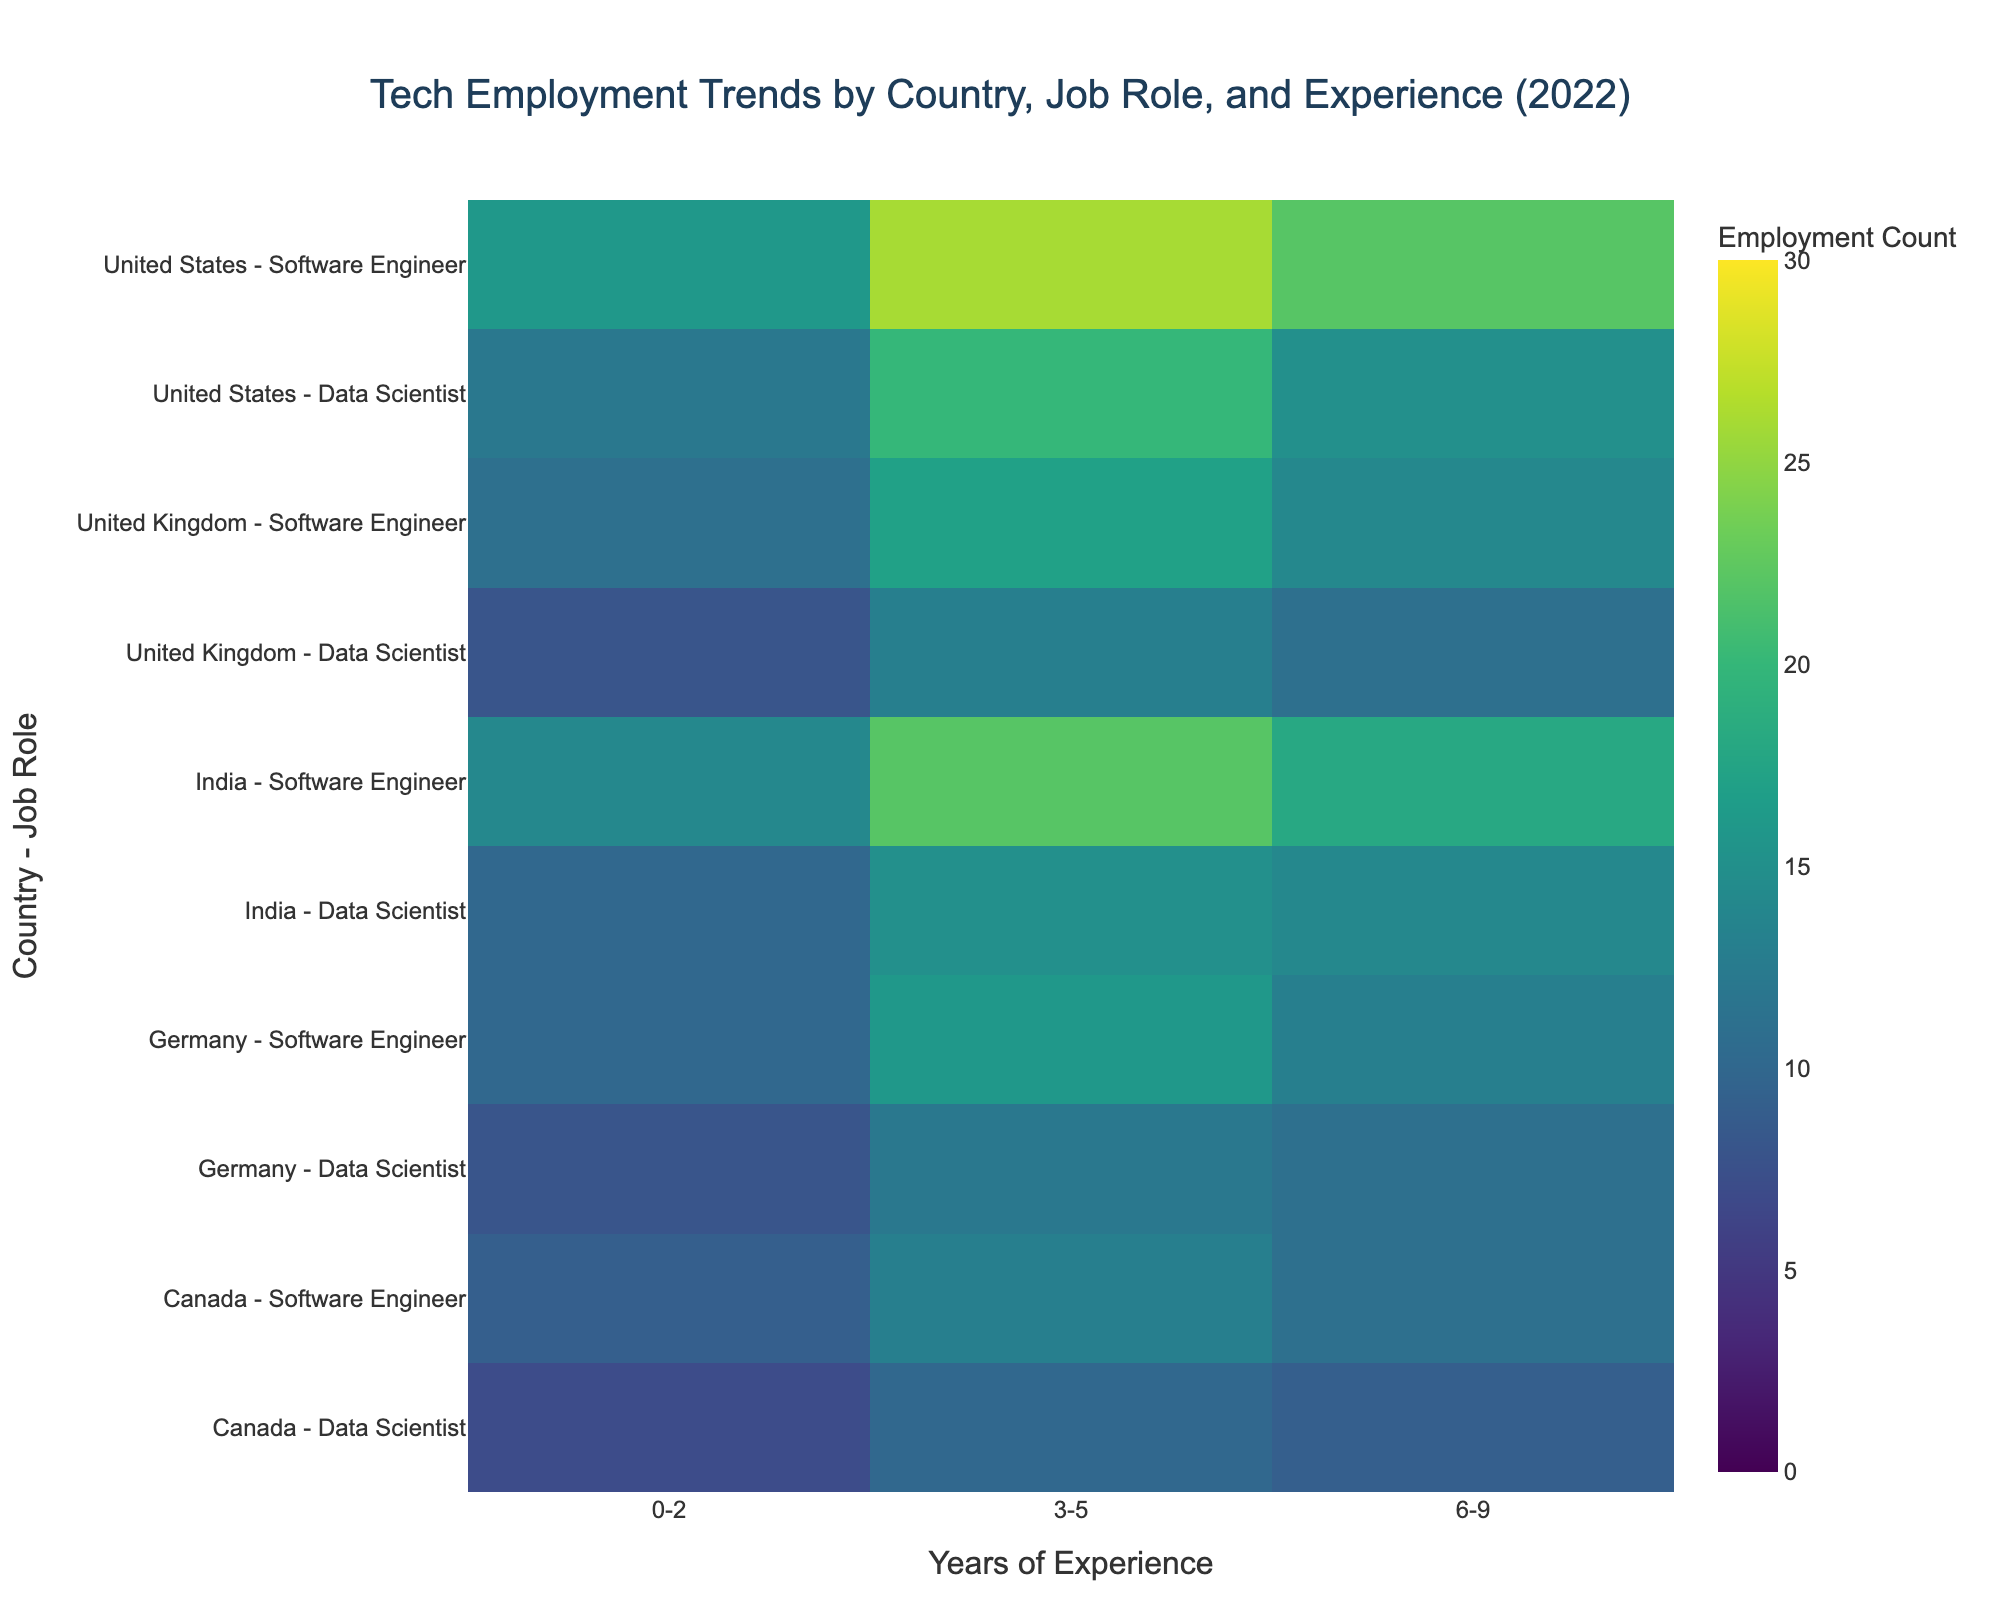What is the title of the heatmap? The title is displayed prominently at the top of the figure, indicating the main subject of the visualization. It reads: "Tech Employment Trends by Country, Job Role, and Experience (2022)."
Answer: Tech Employment Trends by Country, Job Role, and Experience (2022) How many job roles are represented in the heatmap? The y-axis labels are formatted as "Country - Job Role," and each job role repeats across multiple countries. By observing the distinct job roles listed, we see there are two: "Software Engineer" and "Data Scientist."
Answer: 2 Which country has the highest employment count for Software Engineers with 6-9 years of experience? The heatmap cells corresponding to "6-9 years of experience" in the row labels with "Software Engineer" should be examined. Notably, the United States has the darkest cell, indicating the highest count.
Answer: United States What is the employment count for Data Scientists with 0-2 years of experience in the United States? Locate the row labeled "United States - Data Scientist" and follow it to the column for "0-2 years of experience." The value displayed is the employment count.
Answer: 12 Which job role in India shows a higher count for 3-5 years of experience: Software Engineer or Data Scientist? Compare the cells corresponding to the "3-5 years of experience" column for rows labeled "India - Software Engineer" and "India - Data Scientist." "India - Software Engineer" shows a higher count.
Answer: Software Engineer What is the total employment count for Data Scientists with 3-5 years of experience across all countries? Summing up the values in the "3-5 years of experience" column for the "Data Scientist" rows across all countries: 20 (US) + 10 (Canada) + 12 (Germany) + 15 (India) + 13 (UK). The sum is 20 + 10 + 12 + 15 + 13.
Answer: 70 Which country has the least employment count for Software Engineers with 0-2 years of experience? Identify the row labels with "Software Engineer" and check the "0-2 years of experience" column. Canada has the least count among these values.
Answer: Canada How does the employment trend for Software Engineers with 6-9 years of experience differ between the United States and Germany? Compare the cells in "6-9 years of experience" for "United States - Software Engineer" and "Germany - Software Engineer." The United States shows higher employment counts in each year's data as compared to Germany.
Answer: United States has higher counts Which country shows the most balanced employment count across all years of experience for Data Scientists? Visual comparisons across the "Data Scientist" rows and columns will be needed to identify the country with the least variability in cell colors. The United Kingdom shows relatively balanced counts.
Answer: United Kingdom 